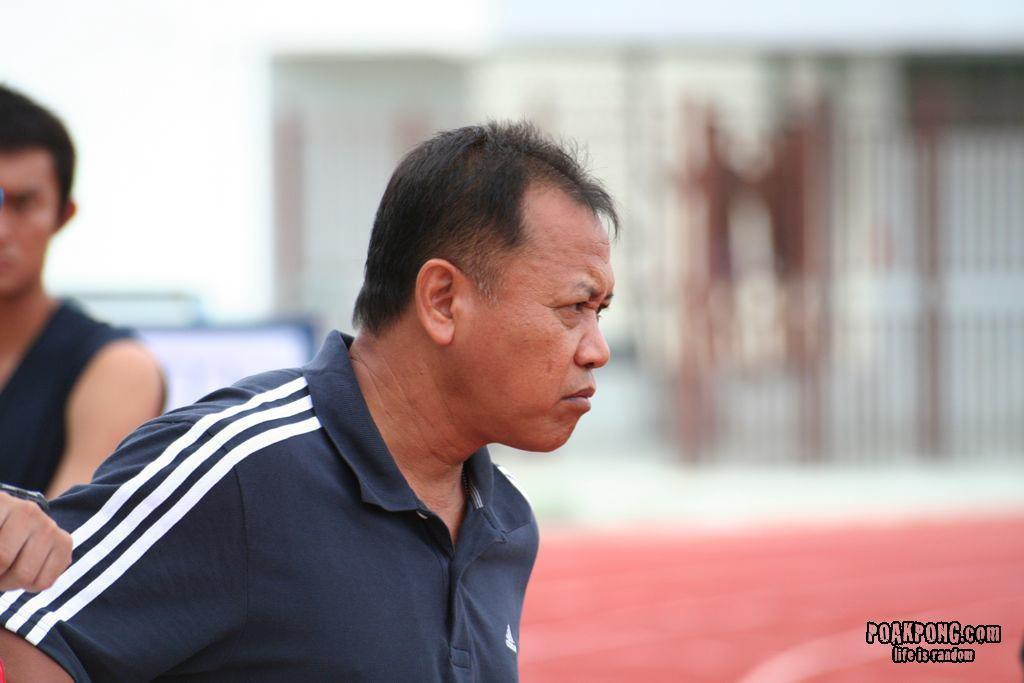How many people are in the image? There are persons in the image, but the exact number is not specified. What are the persons wearing in the image? The persons are wearing blue color T-shirts in the image. What type of feather can be seen on the ice in the image? There is no ice or feather present in the image; it only features persons wearing blue color T-shirts. 